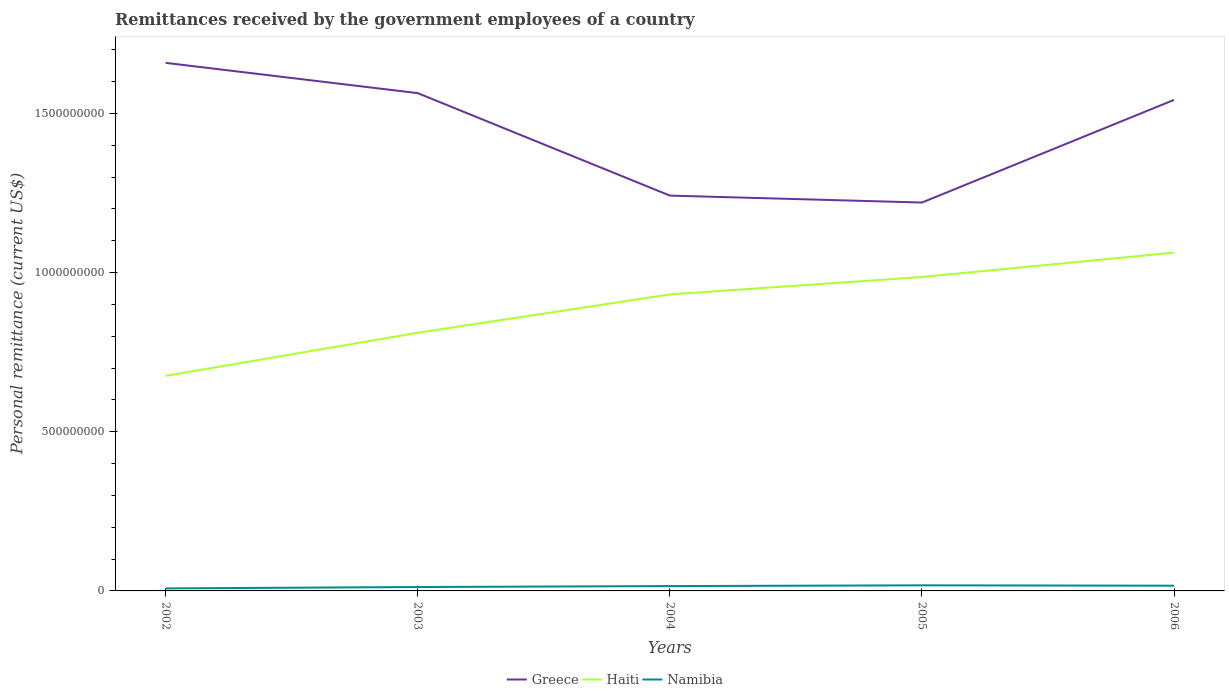Is the number of lines equal to the number of legend labels?
Your response must be concise. Yes. Across all years, what is the maximum remittances received by the government employees in Haiti?
Ensure brevity in your answer.  6.76e+08. In which year was the remittances received by the government employees in Namibia maximum?
Provide a succinct answer. 2002. What is the total remittances received by the government employees in Namibia in the graph?
Provide a succinct answer. -1.20e+06. What is the difference between the highest and the second highest remittances received by the government employees in Namibia?
Give a very brief answer. 9.60e+06. What is the difference between the highest and the lowest remittances received by the government employees in Namibia?
Offer a terse response. 3. Does the graph contain grids?
Offer a terse response. No. Where does the legend appear in the graph?
Ensure brevity in your answer.  Bottom center. How many legend labels are there?
Provide a short and direct response. 3. What is the title of the graph?
Your response must be concise. Remittances received by the government employees of a country. What is the label or title of the Y-axis?
Provide a succinct answer. Personal remittance (current US$). What is the Personal remittance (current US$) of Greece in 2002?
Ensure brevity in your answer.  1.66e+09. What is the Personal remittance (current US$) of Haiti in 2002?
Offer a terse response. 6.76e+08. What is the Personal remittance (current US$) in Namibia in 2002?
Make the answer very short. 7.96e+06. What is the Personal remittance (current US$) in Greece in 2003?
Provide a short and direct response. 1.56e+09. What is the Personal remittance (current US$) in Haiti in 2003?
Your response must be concise. 8.11e+08. What is the Personal remittance (current US$) of Namibia in 2003?
Provide a succinct answer. 1.22e+07. What is the Personal remittance (current US$) in Greece in 2004?
Your answer should be very brief. 1.24e+09. What is the Personal remittance (current US$) of Haiti in 2004?
Offer a very short reply. 9.32e+08. What is the Personal remittance (current US$) in Namibia in 2004?
Offer a very short reply. 1.52e+07. What is the Personal remittance (current US$) in Greece in 2005?
Offer a terse response. 1.22e+09. What is the Personal remittance (current US$) in Haiti in 2005?
Provide a succinct answer. 9.86e+08. What is the Personal remittance (current US$) of Namibia in 2005?
Provide a succinct answer. 1.76e+07. What is the Personal remittance (current US$) of Greece in 2006?
Provide a short and direct response. 1.54e+09. What is the Personal remittance (current US$) of Haiti in 2006?
Ensure brevity in your answer.  1.06e+09. What is the Personal remittance (current US$) of Namibia in 2006?
Make the answer very short. 1.64e+07. Across all years, what is the maximum Personal remittance (current US$) of Greece?
Offer a terse response. 1.66e+09. Across all years, what is the maximum Personal remittance (current US$) of Haiti?
Offer a terse response. 1.06e+09. Across all years, what is the maximum Personal remittance (current US$) in Namibia?
Your response must be concise. 1.76e+07. Across all years, what is the minimum Personal remittance (current US$) in Greece?
Offer a very short reply. 1.22e+09. Across all years, what is the minimum Personal remittance (current US$) in Haiti?
Provide a succinct answer. 6.76e+08. Across all years, what is the minimum Personal remittance (current US$) of Namibia?
Your response must be concise. 7.96e+06. What is the total Personal remittance (current US$) in Greece in the graph?
Keep it short and to the point. 7.23e+09. What is the total Personal remittance (current US$) of Haiti in the graph?
Offer a very short reply. 4.47e+09. What is the total Personal remittance (current US$) in Namibia in the graph?
Keep it short and to the point. 6.94e+07. What is the difference between the Personal remittance (current US$) in Greece in 2002 and that in 2003?
Give a very brief answer. 9.51e+07. What is the difference between the Personal remittance (current US$) in Haiti in 2002 and that in 2003?
Keep it short and to the point. -1.35e+08. What is the difference between the Personal remittance (current US$) in Namibia in 2002 and that in 2003?
Your answer should be very brief. -4.26e+06. What is the difference between the Personal remittance (current US$) of Greece in 2002 and that in 2004?
Your answer should be very brief. 4.17e+08. What is the difference between the Personal remittance (current US$) of Haiti in 2002 and that in 2004?
Keep it short and to the point. -2.56e+08. What is the difference between the Personal remittance (current US$) in Namibia in 2002 and that in 2004?
Keep it short and to the point. -7.28e+06. What is the difference between the Personal remittance (current US$) of Greece in 2002 and that in 2005?
Make the answer very short. 4.39e+08. What is the difference between the Personal remittance (current US$) in Haiti in 2002 and that in 2005?
Offer a very short reply. -3.10e+08. What is the difference between the Personal remittance (current US$) in Namibia in 2002 and that in 2005?
Give a very brief answer. -9.60e+06. What is the difference between the Personal remittance (current US$) in Greece in 2002 and that in 2006?
Make the answer very short. 1.16e+08. What is the difference between the Personal remittance (current US$) in Haiti in 2002 and that in 2006?
Your response must be concise. -3.87e+08. What is the difference between the Personal remittance (current US$) in Namibia in 2002 and that in 2006?
Provide a succinct answer. -8.47e+06. What is the difference between the Personal remittance (current US$) of Greece in 2003 and that in 2004?
Give a very brief answer. 3.22e+08. What is the difference between the Personal remittance (current US$) in Haiti in 2003 and that in 2004?
Offer a terse response. -1.21e+08. What is the difference between the Personal remittance (current US$) in Namibia in 2003 and that in 2004?
Provide a short and direct response. -3.02e+06. What is the difference between the Personal remittance (current US$) in Greece in 2003 and that in 2005?
Your response must be concise. 3.44e+08. What is the difference between the Personal remittance (current US$) in Haiti in 2003 and that in 2005?
Keep it short and to the point. -1.75e+08. What is the difference between the Personal remittance (current US$) in Namibia in 2003 and that in 2005?
Give a very brief answer. -5.34e+06. What is the difference between the Personal remittance (current US$) in Greece in 2003 and that in 2006?
Give a very brief answer. 2.12e+07. What is the difference between the Personal remittance (current US$) of Haiti in 2003 and that in 2006?
Offer a terse response. -2.52e+08. What is the difference between the Personal remittance (current US$) of Namibia in 2003 and that in 2006?
Provide a succinct answer. -4.22e+06. What is the difference between the Personal remittance (current US$) in Greece in 2004 and that in 2005?
Your answer should be compact. 2.18e+07. What is the difference between the Personal remittance (current US$) of Haiti in 2004 and that in 2005?
Offer a very short reply. -5.46e+07. What is the difference between the Personal remittance (current US$) in Namibia in 2004 and that in 2005?
Give a very brief answer. -2.32e+06. What is the difference between the Personal remittance (current US$) of Greece in 2004 and that in 2006?
Provide a succinct answer. -3.01e+08. What is the difference between the Personal remittance (current US$) in Haiti in 2004 and that in 2006?
Your answer should be compact. -1.31e+08. What is the difference between the Personal remittance (current US$) in Namibia in 2004 and that in 2006?
Give a very brief answer. -1.20e+06. What is the difference between the Personal remittance (current US$) in Greece in 2005 and that in 2006?
Make the answer very short. -3.23e+08. What is the difference between the Personal remittance (current US$) of Haiti in 2005 and that in 2006?
Your answer should be very brief. -7.67e+07. What is the difference between the Personal remittance (current US$) in Namibia in 2005 and that in 2006?
Your response must be concise. 1.13e+06. What is the difference between the Personal remittance (current US$) of Greece in 2002 and the Personal remittance (current US$) of Haiti in 2003?
Provide a short and direct response. 8.48e+08. What is the difference between the Personal remittance (current US$) of Greece in 2002 and the Personal remittance (current US$) of Namibia in 2003?
Keep it short and to the point. 1.65e+09. What is the difference between the Personal remittance (current US$) of Haiti in 2002 and the Personal remittance (current US$) of Namibia in 2003?
Ensure brevity in your answer.  6.63e+08. What is the difference between the Personal remittance (current US$) of Greece in 2002 and the Personal remittance (current US$) of Haiti in 2004?
Offer a very short reply. 7.27e+08. What is the difference between the Personal remittance (current US$) of Greece in 2002 and the Personal remittance (current US$) of Namibia in 2004?
Your answer should be very brief. 1.64e+09. What is the difference between the Personal remittance (current US$) in Haiti in 2002 and the Personal remittance (current US$) in Namibia in 2004?
Make the answer very short. 6.60e+08. What is the difference between the Personal remittance (current US$) of Greece in 2002 and the Personal remittance (current US$) of Haiti in 2005?
Keep it short and to the point. 6.73e+08. What is the difference between the Personal remittance (current US$) in Greece in 2002 and the Personal remittance (current US$) in Namibia in 2005?
Your answer should be compact. 1.64e+09. What is the difference between the Personal remittance (current US$) of Haiti in 2002 and the Personal remittance (current US$) of Namibia in 2005?
Keep it short and to the point. 6.58e+08. What is the difference between the Personal remittance (current US$) of Greece in 2002 and the Personal remittance (current US$) of Haiti in 2006?
Offer a very short reply. 5.96e+08. What is the difference between the Personal remittance (current US$) of Greece in 2002 and the Personal remittance (current US$) of Namibia in 2006?
Give a very brief answer. 1.64e+09. What is the difference between the Personal remittance (current US$) in Haiti in 2002 and the Personal remittance (current US$) in Namibia in 2006?
Provide a short and direct response. 6.59e+08. What is the difference between the Personal remittance (current US$) in Greece in 2003 and the Personal remittance (current US$) in Haiti in 2004?
Your answer should be very brief. 6.32e+08. What is the difference between the Personal remittance (current US$) of Greece in 2003 and the Personal remittance (current US$) of Namibia in 2004?
Provide a succinct answer. 1.55e+09. What is the difference between the Personal remittance (current US$) in Haiti in 2003 and the Personal remittance (current US$) in Namibia in 2004?
Your answer should be very brief. 7.96e+08. What is the difference between the Personal remittance (current US$) of Greece in 2003 and the Personal remittance (current US$) of Haiti in 2005?
Ensure brevity in your answer.  5.78e+08. What is the difference between the Personal remittance (current US$) in Greece in 2003 and the Personal remittance (current US$) in Namibia in 2005?
Your response must be concise. 1.55e+09. What is the difference between the Personal remittance (current US$) in Haiti in 2003 and the Personal remittance (current US$) in Namibia in 2005?
Your answer should be very brief. 7.93e+08. What is the difference between the Personal remittance (current US$) in Greece in 2003 and the Personal remittance (current US$) in Haiti in 2006?
Ensure brevity in your answer.  5.01e+08. What is the difference between the Personal remittance (current US$) of Greece in 2003 and the Personal remittance (current US$) of Namibia in 2006?
Make the answer very short. 1.55e+09. What is the difference between the Personal remittance (current US$) in Haiti in 2003 and the Personal remittance (current US$) in Namibia in 2006?
Give a very brief answer. 7.95e+08. What is the difference between the Personal remittance (current US$) of Greece in 2004 and the Personal remittance (current US$) of Haiti in 2005?
Give a very brief answer. 2.56e+08. What is the difference between the Personal remittance (current US$) of Greece in 2004 and the Personal remittance (current US$) of Namibia in 2005?
Provide a succinct answer. 1.22e+09. What is the difference between the Personal remittance (current US$) in Haiti in 2004 and the Personal remittance (current US$) in Namibia in 2005?
Offer a terse response. 9.14e+08. What is the difference between the Personal remittance (current US$) in Greece in 2004 and the Personal remittance (current US$) in Haiti in 2006?
Offer a very short reply. 1.79e+08. What is the difference between the Personal remittance (current US$) of Greece in 2004 and the Personal remittance (current US$) of Namibia in 2006?
Your response must be concise. 1.23e+09. What is the difference between the Personal remittance (current US$) in Haiti in 2004 and the Personal remittance (current US$) in Namibia in 2006?
Your answer should be compact. 9.15e+08. What is the difference between the Personal remittance (current US$) in Greece in 2005 and the Personal remittance (current US$) in Haiti in 2006?
Provide a succinct answer. 1.57e+08. What is the difference between the Personal remittance (current US$) in Greece in 2005 and the Personal remittance (current US$) in Namibia in 2006?
Provide a short and direct response. 1.20e+09. What is the difference between the Personal remittance (current US$) of Haiti in 2005 and the Personal remittance (current US$) of Namibia in 2006?
Your response must be concise. 9.70e+08. What is the average Personal remittance (current US$) of Greece per year?
Your answer should be very brief. 1.45e+09. What is the average Personal remittance (current US$) of Haiti per year?
Your answer should be very brief. 8.93e+08. What is the average Personal remittance (current US$) of Namibia per year?
Provide a succinct answer. 1.39e+07. In the year 2002, what is the difference between the Personal remittance (current US$) in Greece and Personal remittance (current US$) in Haiti?
Offer a very short reply. 9.83e+08. In the year 2002, what is the difference between the Personal remittance (current US$) in Greece and Personal remittance (current US$) in Namibia?
Provide a succinct answer. 1.65e+09. In the year 2002, what is the difference between the Personal remittance (current US$) of Haiti and Personal remittance (current US$) of Namibia?
Provide a succinct answer. 6.68e+08. In the year 2003, what is the difference between the Personal remittance (current US$) in Greece and Personal remittance (current US$) in Haiti?
Make the answer very short. 7.53e+08. In the year 2003, what is the difference between the Personal remittance (current US$) in Greece and Personal remittance (current US$) in Namibia?
Provide a succinct answer. 1.55e+09. In the year 2003, what is the difference between the Personal remittance (current US$) of Haiti and Personal remittance (current US$) of Namibia?
Your answer should be compact. 7.99e+08. In the year 2004, what is the difference between the Personal remittance (current US$) in Greece and Personal remittance (current US$) in Haiti?
Your response must be concise. 3.10e+08. In the year 2004, what is the difference between the Personal remittance (current US$) in Greece and Personal remittance (current US$) in Namibia?
Offer a terse response. 1.23e+09. In the year 2004, what is the difference between the Personal remittance (current US$) of Haiti and Personal remittance (current US$) of Namibia?
Make the answer very short. 9.16e+08. In the year 2005, what is the difference between the Personal remittance (current US$) in Greece and Personal remittance (current US$) in Haiti?
Offer a terse response. 2.34e+08. In the year 2005, what is the difference between the Personal remittance (current US$) in Greece and Personal remittance (current US$) in Namibia?
Offer a terse response. 1.20e+09. In the year 2005, what is the difference between the Personal remittance (current US$) in Haiti and Personal remittance (current US$) in Namibia?
Your answer should be very brief. 9.69e+08. In the year 2006, what is the difference between the Personal remittance (current US$) of Greece and Personal remittance (current US$) of Haiti?
Your answer should be compact. 4.80e+08. In the year 2006, what is the difference between the Personal remittance (current US$) in Greece and Personal remittance (current US$) in Namibia?
Offer a terse response. 1.53e+09. In the year 2006, what is the difference between the Personal remittance (current US$) of Haiti and Personal remittance (current US$) of Namibia?
Ensure brevity in your answer.  1.05e+09. What is the ratio of the Personal remittance (current US$) of Greece in 2002 to that in 2003?
Offer a terse response. 1.06. What is the ratio of the Personal remittance (current US$) in Haiti in 2002 to that in 2003?
Keep it short and to the point. 0.83. What is the ratio of the Personal remittance (current US$) of Namibia in 2002 to that in 2003?
Your answer should be compact. 0.65. What is the ratio of the Personal remittance (current US$) of Greece in 2002 to that in 2004?
Your answer should be compact. 1.34. What is the ratio of the Personal remittance (current US$) in Haiti in 2002 to that in 2004?
Ensure brevity in your answer.  0.73. What is the ratio of the Personal remittance (current US$) of Namibia in 2002 to that in 2004?
Provide a succinct answer. 0.52. What is the ratio of the Personal remittance (current US$) in Greece in 2002 to that in 2005?
Your answer should be very brief. 1.36. What is the ratio of the Personal remittance (current US$) of Haiti in 2002 to that in 2005?
Provide a short and direct response. 0.69. What is the ratio of the Personal remittance (current US$) of Namibia in 2002 to that in 2005?
Offer a terse response. 0.45. What is the ratio of the Personal remittance (current US$) in Greece in 2002 to that in 2006?
Offer a terse response. 1.08. What is the ratio of the Personal remittance (current US$) in Haiti in 2002 to that in 2006?
Your response must be concise. 0.64. What is the ratio of the Personal remittance (current US$) of Namibia in 2002 to that in 2006?
Provide a short and direct response. 0.48. What is the ratio of the Personal remittance (current US$) of Greece in 2003 to that in 2004?
Ensure brevity in your answer.  1.26. What is the ratio of the Personal remittance (current US$) of Haiti in 2003 to that in 2004?
Ensure brevity in your answer.  0.87. What is the ratio of the Personal remittance (current US$) in Namibia in 2003 to that in 2004?
Give a very brief answer. 0.8. What is the ratio of the Personal remittance (current US$) of Greece in 2003 to that in 2005?
Provide a short and direct response. 1.28. What is the ratio of the Personal remittance (current US$) of Haiti in 2003 to that in 2005?
Offer a terse response. 0.82. What is the ratio of the Personal remittance (current US$) of Namibia in 2003 to that in 2005?
Your answer should be very brief. 0.7. What is the ratio of the Personal remittance (current US$) in Greece in 2003 to that in 2006?
Provide a short and direct response. 1.01. What is the ratio of the Personal remittance (current US$) of Haiti in 2003 to that in 2006?
Provide a succinct answer. 0.76. What is the ratio of the Personal remittance (current US$) in Namibia in 2003 to that in 2006?
Make the answer very short. 0.74. What is the ratio of the Personal remittance (current US$) of Greece in 2004 to that in 2005?
Offer a very short reply. 1.02. What is the ratio of the Personal remittance (current US$) in Haiti in 2004 to that in 2005?
Provide a short and direct response. 0.94. What is the ratio of the Personal remittance (current US$) of Namibia in 2004 to that in 2005?
Provide a short and direct response. 0.87. What is the ratio of the Personal remittance (current US$) in Greece in 2004 to that in 2006?
Your response must be concise. 0.81. What is the ratio of the Personal remittance (current US$) of Haiti in 2004 to that in 2006?
Provide a short and direct response. 0.88. What is the ratio of the Personal remittance (current US$) of Namibia in 2004 to that in 2006?
Offer a terse response. 0.93. What is the ratio of the Personal remittance (current US$) in Greece in 2005 to that in 2006?
Your answer should be very brief. 0.79. What is the ratio of the Personal remittance (current US$) of Haiti in 2005 to that in 2006?
Your answer should be compact. 0.93. What is the ratio of the Personal remittance (current US$) of Namibia in 2005 to that in 2006?
Your answer should be compact. 1.07. What is the difference between the highest and the second highest Personal remittance (current US$) in Greece?
Your response must be concise. 9.51e+07. What is the difference between the highest and the second highest Personal remittance (current US$) in Haiti?
Provide a succinct answer. 7.67e+07. What is the difference between the highest and the second highest Personal remittance (current US$) of Namibia?
Provide a succinct answer. 1.13e+06. What is the difference between the highest and the lowest Personal remittance (current US$) in Greece?
Your answer should be very brief. 4.39e+08. What is the difference between the highest and the lowest Personal remittance (current US$) of Haiti?
Provide a short and direct response. 3.87e+08. What is the difference between the highest and the lowest Personal remittance (current US$) of Namibia?
Your answer should be very brief. 9.60e+06. 